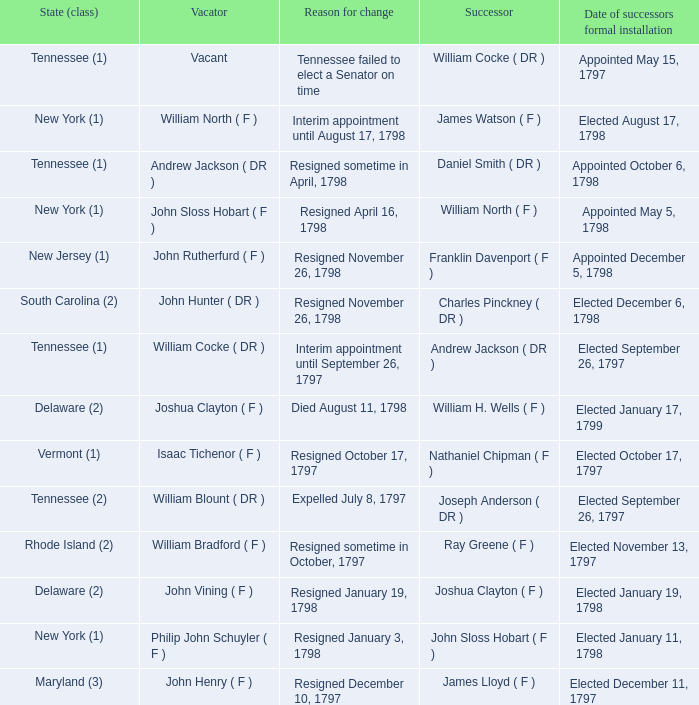What is the total number of dates of successor formal installation when the vacator was Joshua Clayton ( F )? 1.0. 